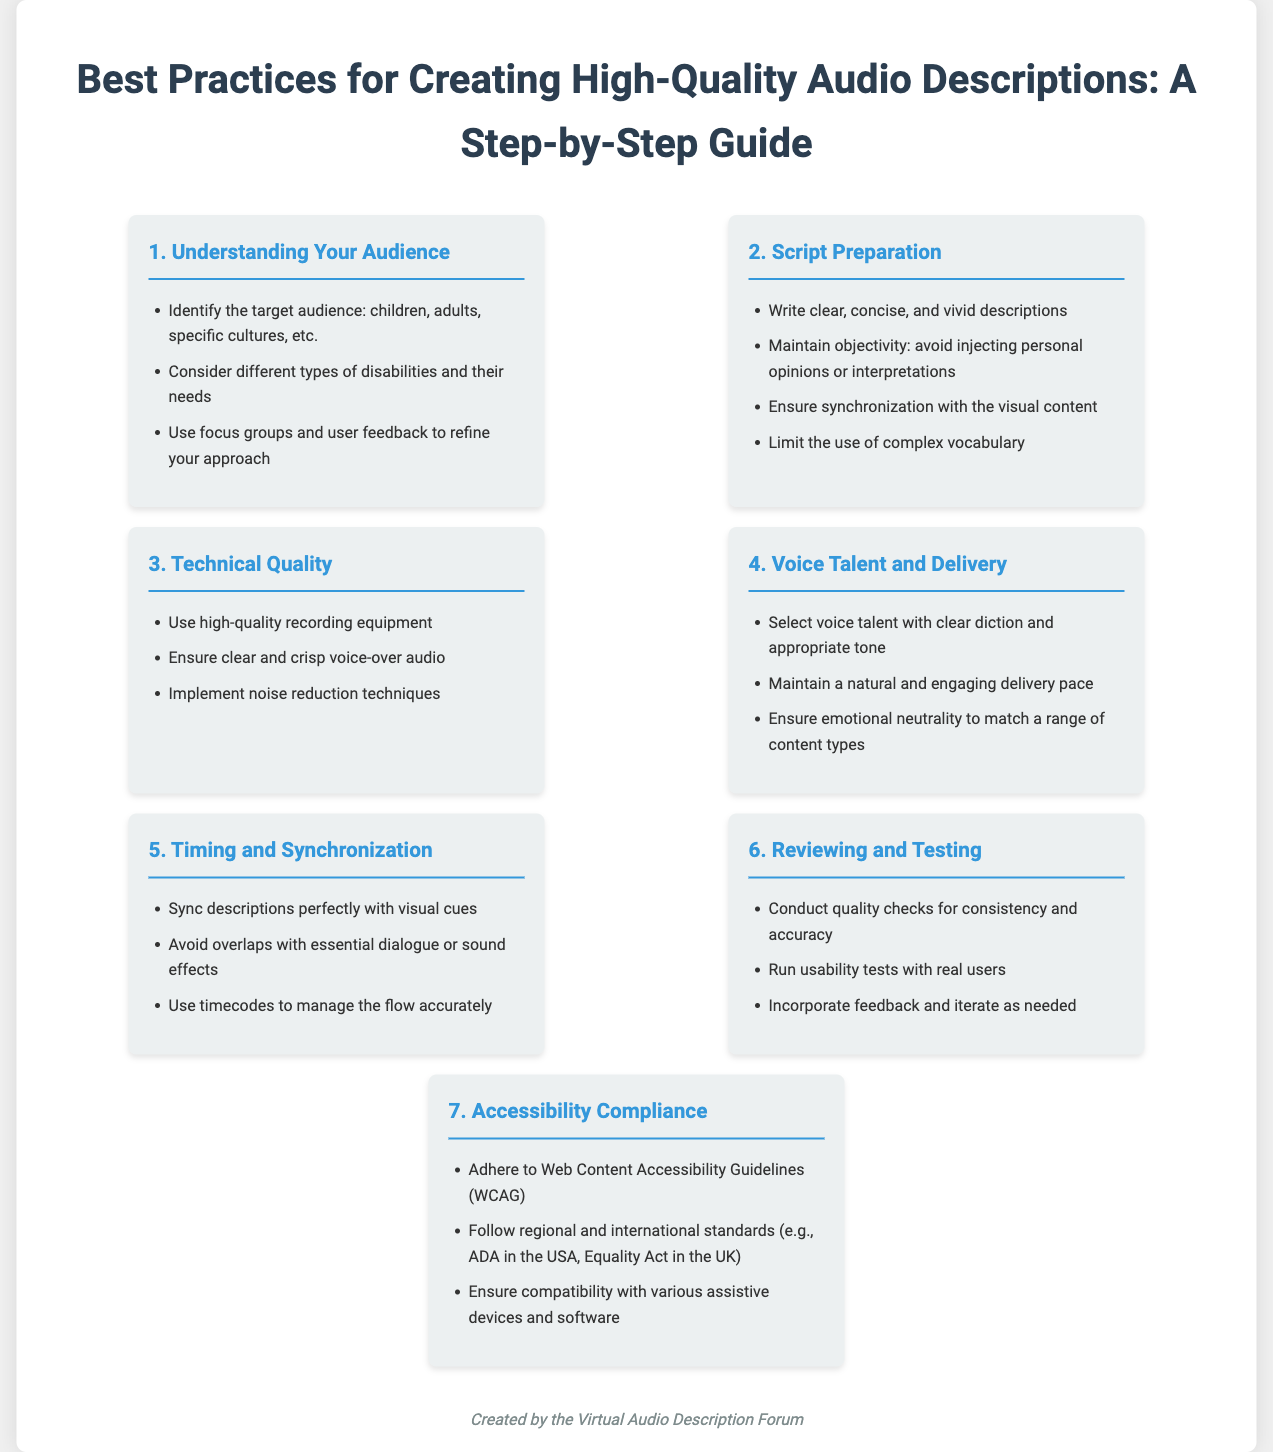What are the seven steps for creating high-quality audio descriptions? The document outlines seven steps: Understanding Your Audience, Script Preparation, Technical Quality, Voice Talent and Delivery, Timing and Synchronization, Reviewing and Testing, and Accessibility Compliance.
Answer: Seven steps What should be limited in the script preparation? The script preparation section advises limiting the use of complex vocabulary to enhance understanding.
Answer: Complex vocabulary Which guideline is mentioned for accessibility compliance? The document states that adherence to Web Content Accessibility Guidelines (WCAG) is crucial for ensuring accessibility compliance.
Answer: WCAG What is a key consideration when selecting voice talent? A key consideration is to select voice talent with clear diction and appropriate tone for the audio description.
Answer: Clear diction What should be achieved during the reviewing and testing phase? The reviewing and testing phase should conduct quality checks for consistency and accuracy in audio descriptions.
Answer: Quality checks What type of feedback should be used to refine the approach in understanding the audience? The emphasis is on using focus groups and user feedback to refine the approach regarding the audience's needs.
Answer: User feedback What is an essential timing consideration for audio descriptions? A vital timing consideration is to sync descriptions perfectly with visual cues to enhance the viewer's experience.
Answer: Sync descriptions Which international standards are mentioned regarding accessibility compliance? The document refers to regional and international standards such as ADA in the USA and Equality Act in the UK for accessibility compliance.
Answer: ADA and Equality Act 